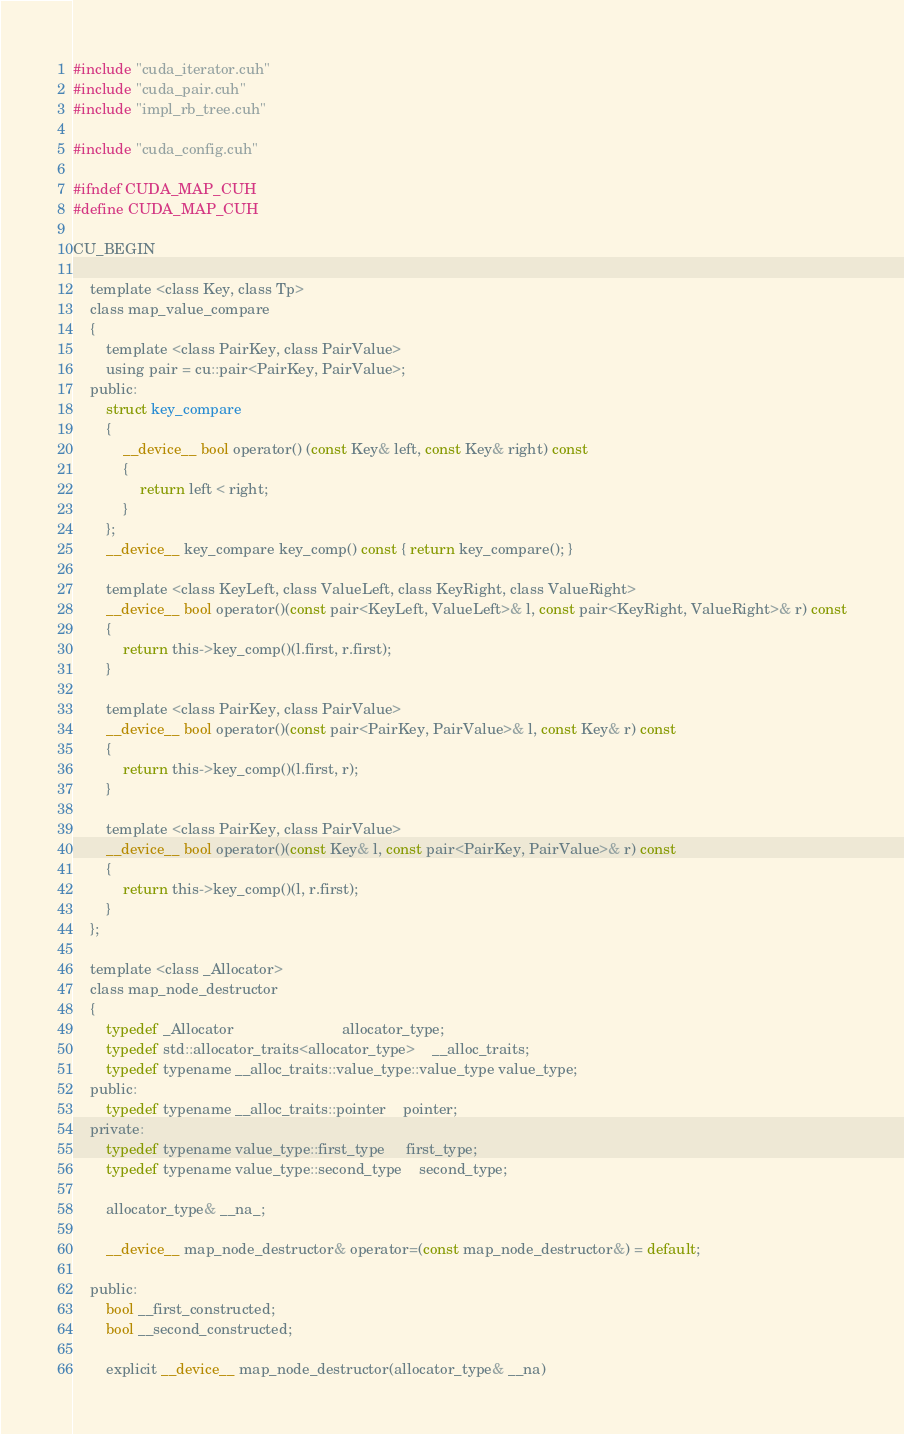Convert code to text. <code><loc_0><loc_0><loc_500><loc_500><_Cuda_>#include "cuda_iterator.cuh"
#include "cuda_pair.cuh"
#include "impl_rb_tree.cuh"

#include "cuda_config.cuh"

#ifndef CUDA_MAP_CUH
#define CUDA_MAP_CUH

CU_BEGIN

	template <class Key, class Tp>
	class map_value_compare
	{
		template <class PairKey, class PairValue>
		using pair = cu::pair<PairKey, PairValue>;
	public:
		struct key_compare
		{
			__device__ bool operator() (const Key& left, const Key& right) const
			{
				return left < right;
			}
		};
		__device__ key_compare key_comp() const { return key_compare(); }

		template <class KeyLeft, class ValueLeft, class KeyRight, class ValueRight>
		__device__ bool operator()(const pair<KeyLeft, ValueLeft>& l, const pair<KeyRight, ValueRight>& r) const
		{
			return this->key_comp()(l.first, r.first);
		}

		template <class PairKey, class PairValue>
		__device__ bool operator()(const pair<PairKey, PairValue>& l, const Key& r) const
		{
			return this->key_comp()(l.first, r);
		}

		template <class PairKey, class PairValue>
		__device__ bool operator()(const Key& l, const pair<PairKey, PairValue>& r) const
		{
			return this->key_comp()(l, r.first);
		}
	};

	template <class _Allocator>
	class map_node_destructor
	{
		typedef _Allocator                          allocator_type;
		typedef std::allocator_traits<allocator_type>    __alloc_traits;
		typedef typename __alloc_traits::value_type::value_type value_type;
	public:
		typedef typename __alloc_traits::pointer    pointer;
	private:
		typedef typename value_type::first_type     first_type;
		typedef typename value_type::second_type    second_type;

		allocator_type& __na_;

		__device__ map_node_destructor& operator=(const map_node_destructor&) = default;

	public:
		bool __first_constructed;
		bool __second_constructed;

		explicit __device__ map_node_destructor(allocator_type& __na)</code> 